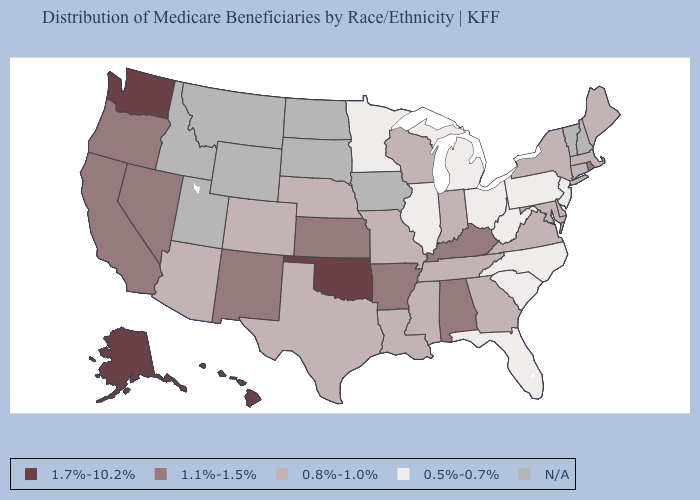Name the states that have a value in the range N/A?
Write a very short answer. Idaho, Iowa, Montana, New Hampshire, North Dakota, South Dakota, Utah, Vermont, Wyoming. Name the states that have a value in the range 1.7%-10.2%?
Concise answer only. Alaska, Hawaii, Oklahoma, Washington. Name the states that have a value in the range N/A?
Keep it brief. Idaho, Iowa, Montana, New Hampshire, North Dakota, South Dakota, Utah, Vermont, Wyoming. How many symbols are there in the legend?
Give a very brief answer. 5. What is the value of New York?
Concise answer only. 0.8%-1.0%. Does Illinois have the highest value in the USA?
Quick response, please. No. What is the value of South Carolina?
Short answer required. 0.5%-0.7%. What is the value of Idaho?
Be succinct. N/A. Name the states that have a value in the range 0.8%-1.0%?
Answer briefly. Arizona, Colorado, Connecticut, Delaware, Georgia, Indiana, Louisiana, Maine, Maryland, Massachusetts, Mississippi, Missouri, Nebraska, New York, Tennessee, Texas, Virginia, Wisconsin. What is the value of North Dakota?
Short answer required. N/A. Among the states that border Oklahoma , which have the lowest value?
Answer briefly. Colorado, Missouri, Texas. Name the states that have a value in the range 1.1%-1.5%?
Be succinct. Alabama, Arkansas, California, Kansas, Kentucky, Nevada, New Mexico, Oregon, Rhode Island. 